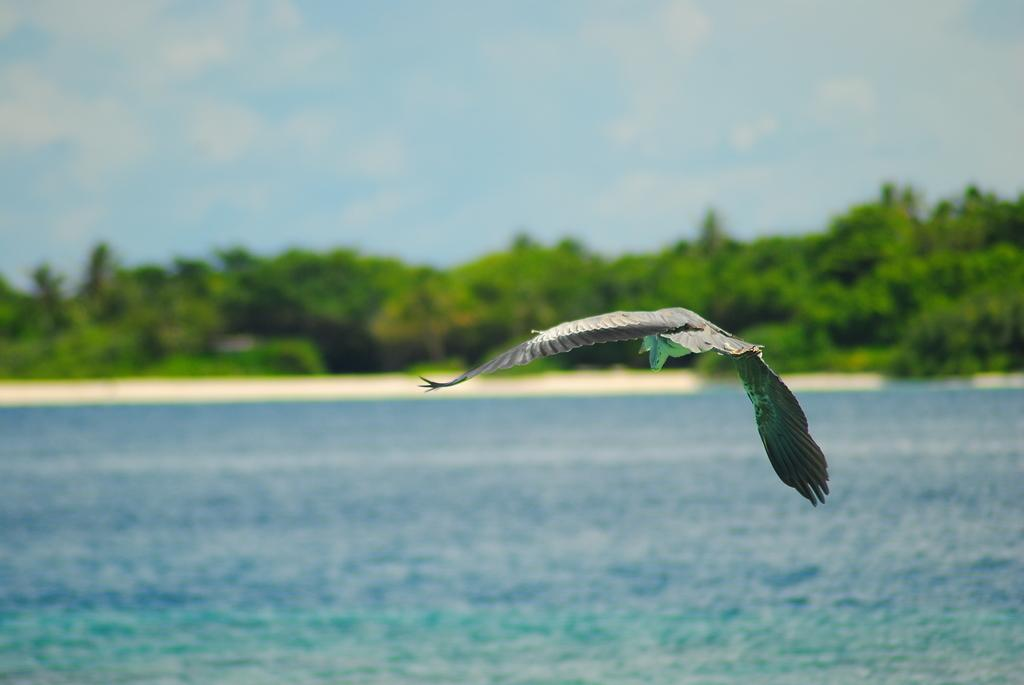What type of animal can be seen in the image? There is a bird in the image. What is the primary element in which the bird is situated? The bird is situated in water. What can be seen in the background of the image? There are trees in the image. What part of the natural environment is visible in the image? The sky is visible in the image. Where is the cave located in the image? There is no cave present in the image. Can you see a beetle crawling on the bird in the image? There is no beetle present in the image. 